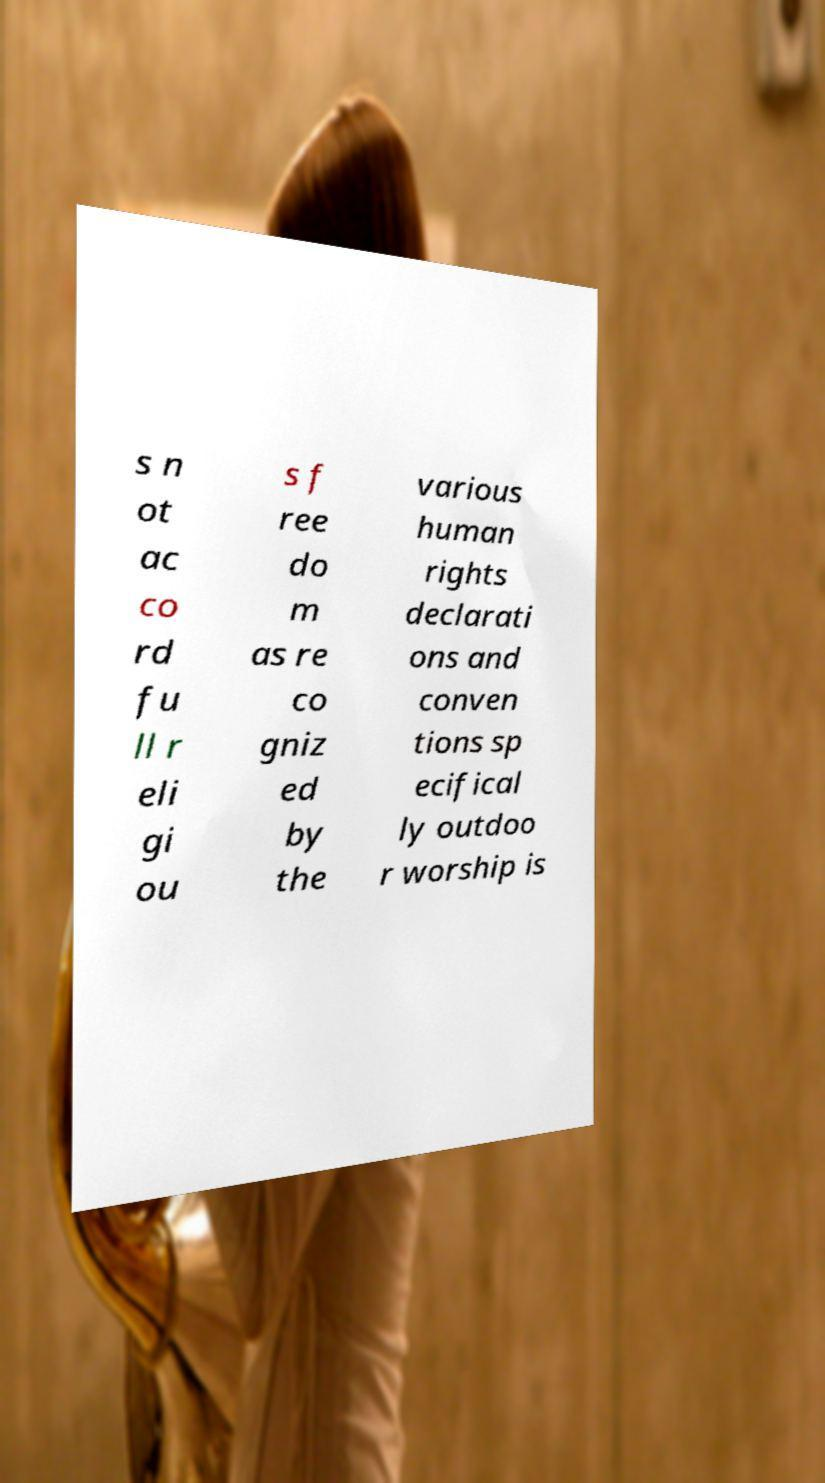There's text embedded in this image that I need extracted. Can you transcribe it verbatim? s n ot ac co rd fu ll r eli gi ou s f ree do m as re co gniz ed by the various human rights declarati ons and conven tions sp ecifical ly outdoo r worship is 